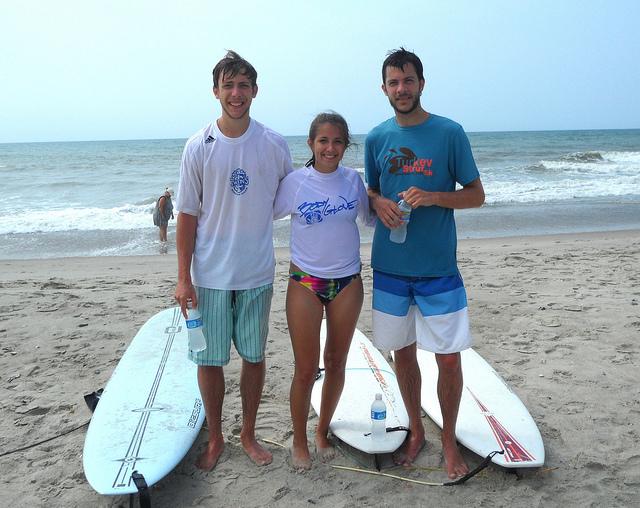Where are the surfboards?
Concise answer only. On ground. Who is drinking water?
Write a very short answer. Men. Are the going to go surfing?
Keep it brief. Yes. 